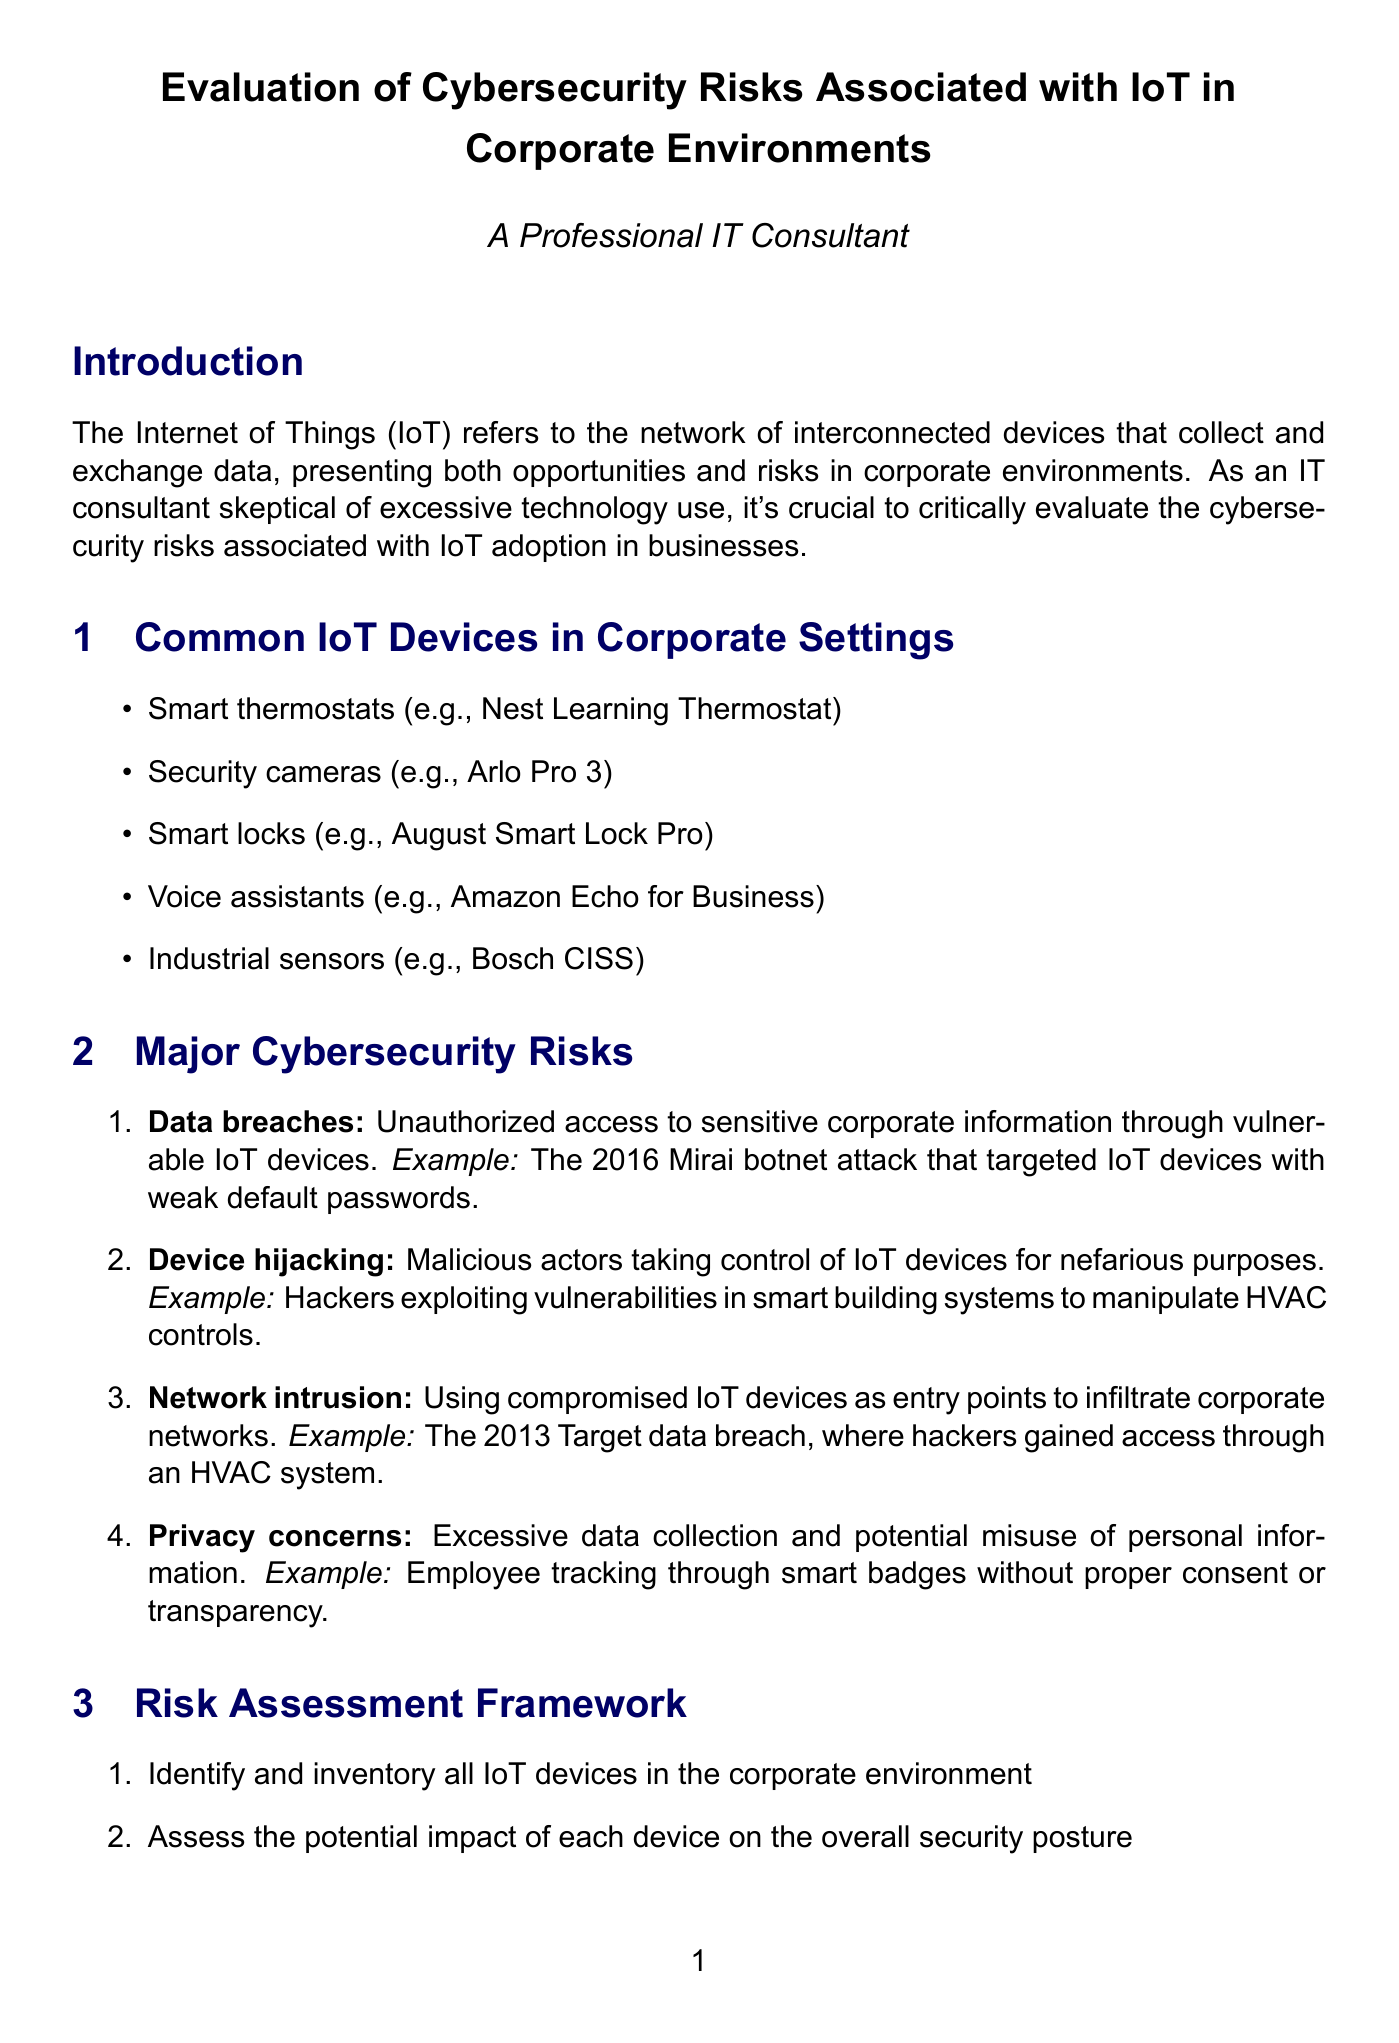What is the definition of IoT? The document defines IoT as "the network of interconnected devices that collect and exchange data, presenting both opportunities and risks in corporate environments."
Answer: the network of interconnected devices that collect and exchange data What is one example of a data breach? The document provides the example of "The 2016 Mirai botnet attack that targeted IoT devices with weak default passwords."
Answer: The 2016 Mirai botnet attack How many steps are in the risk assessment framework? The document outlines a five-step process for the risk assessment framework.
Answer: five What is the tool suggested for strong authentication? The document mentions "Duo Security for MFA implementation" as the tool.
Answer: Duo Security for MFA implementation What regulation ensures proper handling of personal data in the EU? The document states that the "General Data Protection Regulation (GDPR)" ensures proper handling of personal data.
Answer: General Data Protection Regulation (GDPR) Which IoT device is mentioned as an example of smart locks? The document lists "August Smart Lock Pro" as an example of smart locks.
Answer: August Smart Lock Pro What is the first step in the risk assessment framework? The document lists "Identify and inventory all IoT devices in the corporate environment" as the first step.
Answer: Identify and inventory all IoT devices in the corporate environment What is the main recommendation in the conclusion? The document recommends that organizations "implement a comprehensive risk assessment and mitigation strategy before deploying IoT solutions."
Answer: implement a comprehensive risk assessment and mitigation strategy 